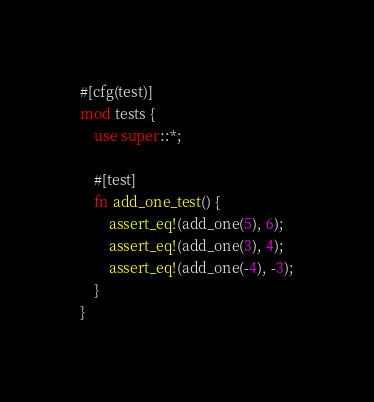Convert code to text. <code><loc_0><loc_0><loc_500><loc_500><_Rust_>
#[cfg(test)]
mod tests {
    use super::*;

    #[test]
    fn add_one_test() {
        assert_eq!(add_one(5), 6);
        assert_eq!(add_one(3), 4);
        assert_eq!(add_one(-4), -3);
    }
}
</code> 